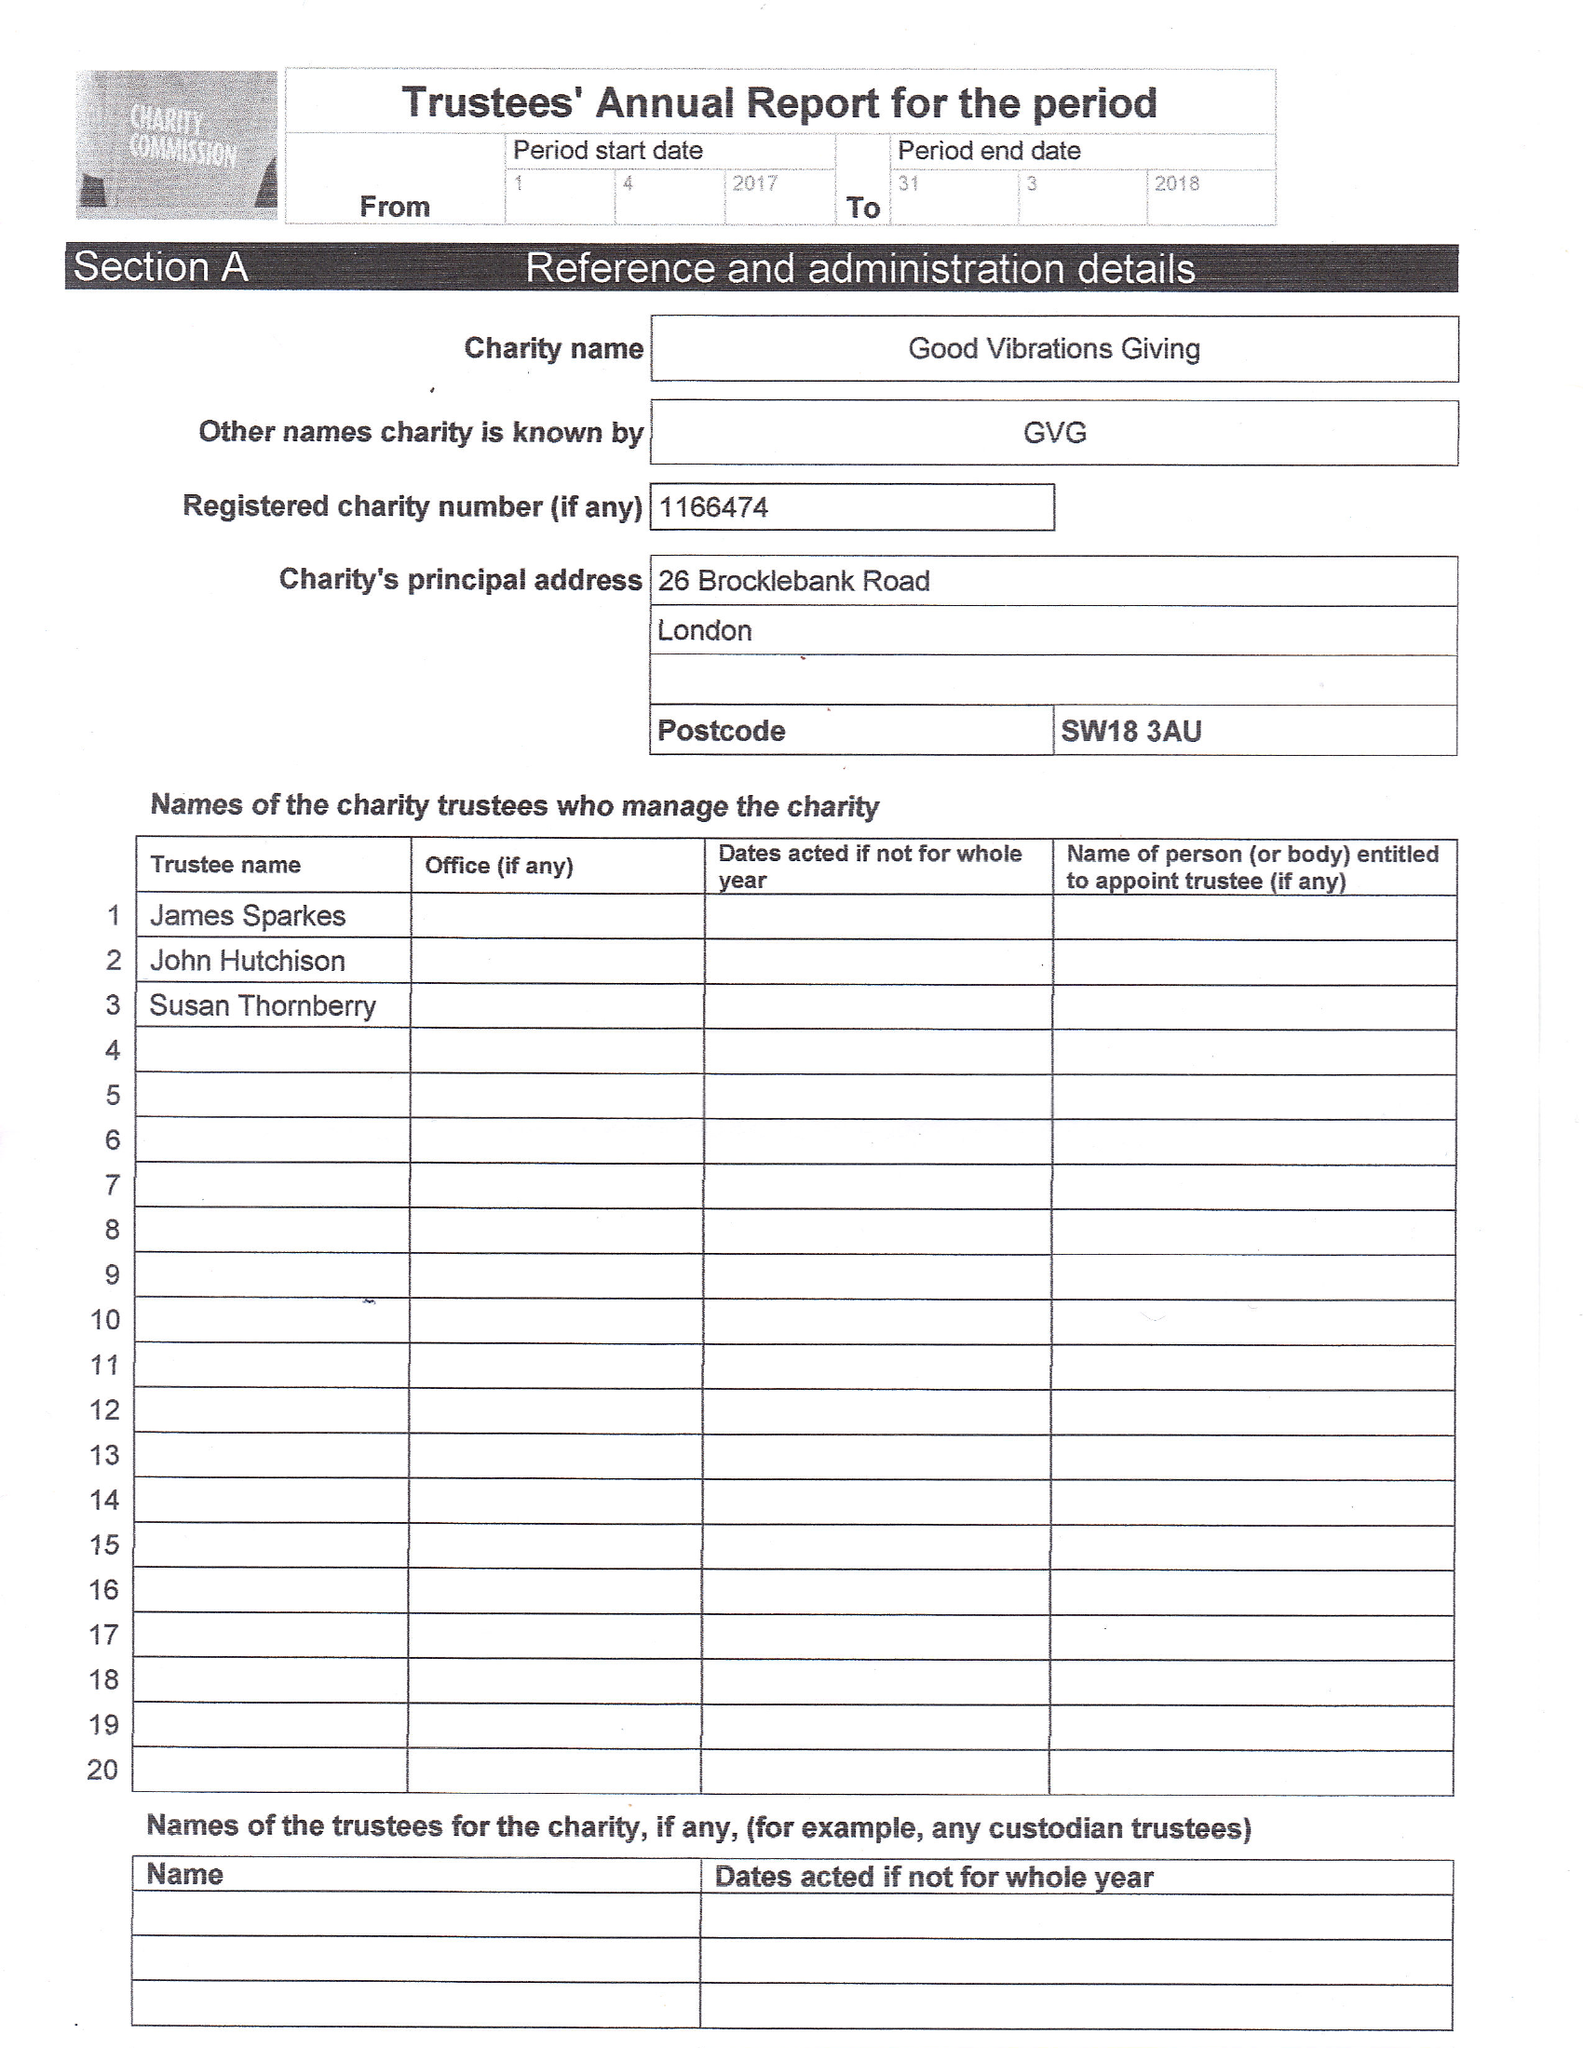What is the value for the income_annually_in_british_pounds?
Answer the question using a single word or phrase. 3517.00 